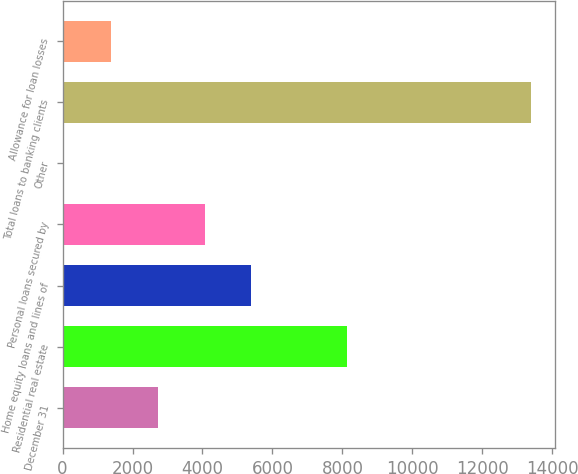Convert chart. <chart><loc_0><loc_0><loc_500><loc_500><bar_chart><fcel>December 31<fcel>Residential real estate<fcel>Home equity loans and lines of<fcel>Personal loans secured by<fcel>Other<fcel>Total loans to banking clients<fcel>Allowance for loan losses<nl><fcel>2719.4<fcel>8127<fcel>5399.8<fcel>4059.6<fcel>39<fcel>13399<fcel>1379.2<nl></chart> 